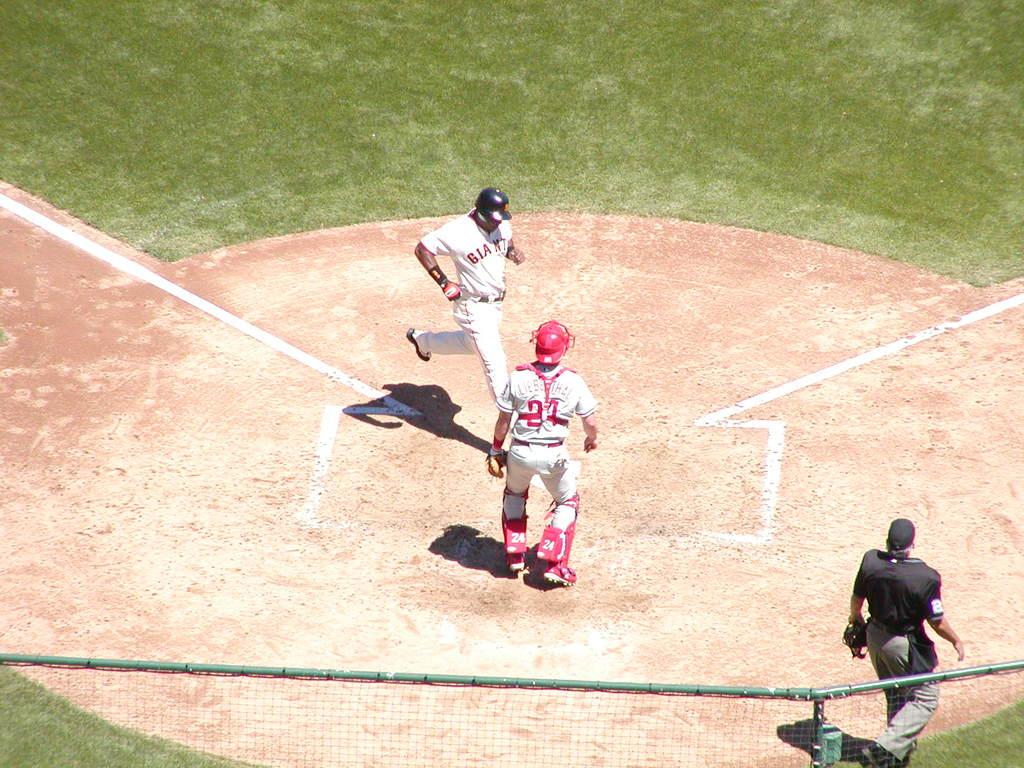<image>
Describe the image concisely. the name of the catcher in the game is Lieberthal 